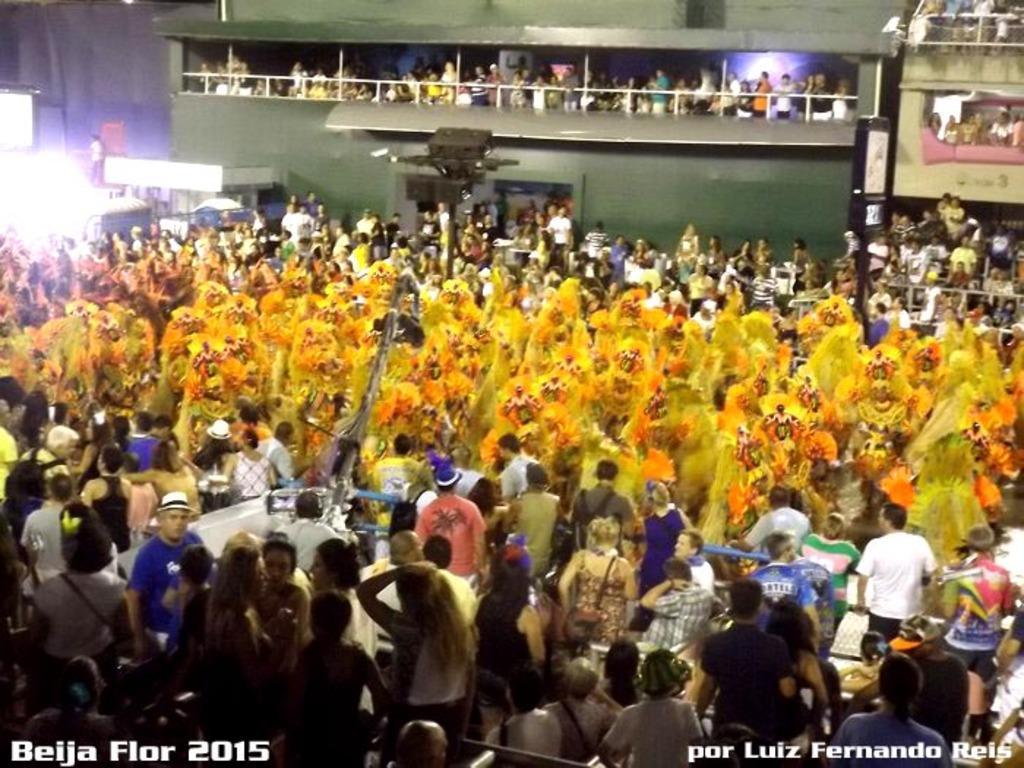Can you describe this image briefly? People are present. people are present at the center wearing yellow costumes. Few people are present at the top. 